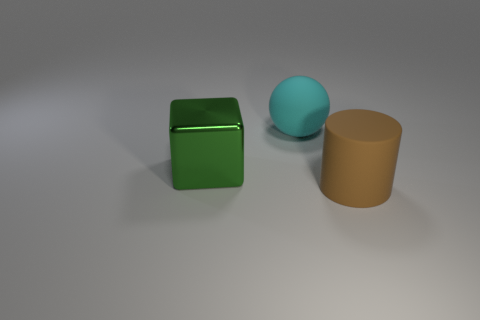Add 1 big rubber cylinders. How many objects exist? 4 Subtract 1 spheres. How many spheres are left? 0 Add 1 blue balls. How many blue balls exist? 1 Subtract 1 cyan balls. How many objects are left? 2 Subtract all yellow cylinders. Subtract all blue blocks. How many cylinders are left? 1 Subtract all big metallic blocks. Subtract all cyan spheres. How many objects are left? 1 Add 2 green metal blocks. How many green metal blocks are left? 3 